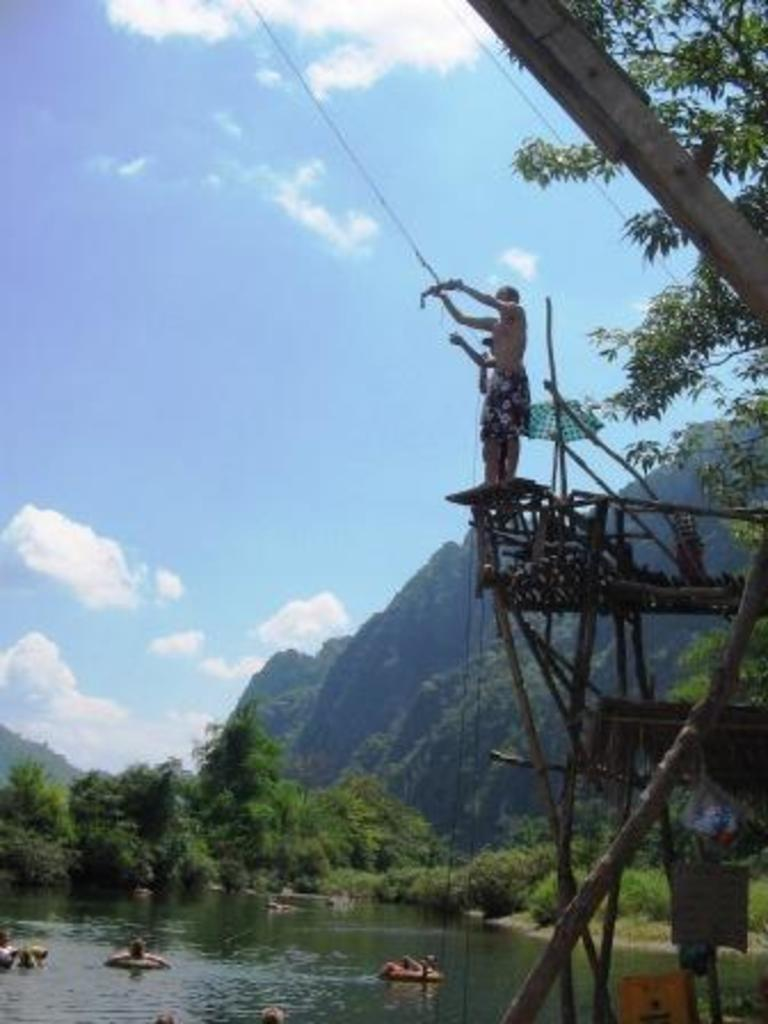Who or what can be seen in the image? There are people in the image. What structure is present in the image? There is a wooden bridge in the image. What object is visible in the image that might be used for protection from the rain? There is an umbrella in the image. What type of vegetation is present in the image? Trees are present in the image. What geographical feature can be seen in the image? There are hills in the image. What natural element is visible in the image? There is water visible in the image. What is visible at the top of the image? The sky is visible at the top of the image. What can be seen in the sky in the image? Clouds are present in the sky. Can you tell me which actor is performing on the wooden bridge in the image? There is no actor performing on the wooden bridge in the image. Is there a giraffe visible in the image? There is no giraffe present in the image. 